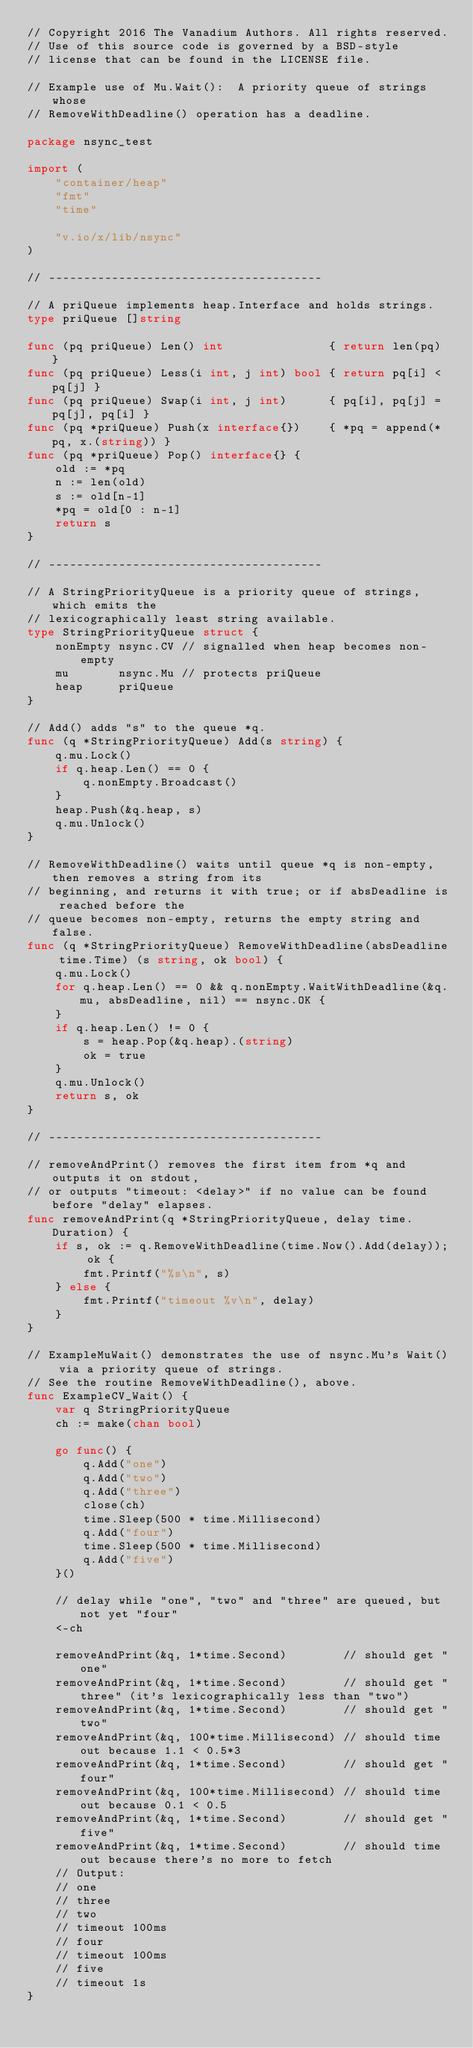<code> <loc_0><loc_0><loc_500><loc_500><_Go_>// Copyright 2016 The Vanadium Authors. All rights reserved.
// Use of this source code is governed by a BSD-style
// license that can be found in the LICENSE file.

// Example use of Mu.Wait():  A priority queue of strings whose
// RemoveWithDeadline() operation has a deadline.

package nsync_test

import (
	"container/heap"
	"fmt"
	"time"

	"v.io/x/lib/nsync"
)

// ---------------------------------------

// A priQueue implements heap.Interface and holds strings.
type priQueue []string

func (pq priQueue) Len() int               { return len(pq) }
func (pq priQueue) Less(i int, j int) bool { return pq[i] < pq[j] }
func (pq priQueue) Swap(i int, j int)      { pq[i], pq[j] = pq[j], pq[i] }
func (pq *priQueue) Push(x interface{})    { *pq = append(*pq, x.(string)) }
func (pq *priQueue) Pop() interface{} {
	old := *pq
	n := len(old)
	s := old[n-1]
	*pq = old[0 : n-1]
	return s
}

// ---------------------------------------

// A StringPriorityQueue is a priority queue of strings, which emits the
// lexicographically least string available.
type StringPriorityQueue struct {
	nonEmpty nsync.CV // signalled when heap becomes non-empty
	mu       nsync.Mu // protects priQueue
	heap     priQueue
}

// Add() adds "s" to the queue *q.
func (q *StringPriorityQueue) Add(s string) {
	q.mu.Lock()
	if q.heap.Len() == 0 {
		q.nonEmpty.Broadcast()
	}
	heap.Push(&q.heap, s)
	q.mu.Unlock()
}

// RemoveWithDeadline() waits until queue *q is non-empty, then removes a string from its
// beginning, and returns it with true; or if absDeadline is reached before the
// queue becomes non-empty, returns the empty string and false.
func (q *StringPriorityQueue) RemoveWithDeadline(absDeadline time.Time) (s string, ok bool) {
	q.mu.Lock()
	for q.heap.Len() == 0 && q.nonEmpty.WaitWithDeadline(&q.mu, absDeadline, nil) == nsync.OK {
	}
	if q.heap.Len() != 0 {
		s = heap.Pop(&q.heap).(string)
		ok = true
	}
	q.mu.Unlock()
	return s, ok
}

// ---------------------------------------

// removeAndPrint() removes the first item from *q and outputs it on stdout,
// or outputs "timeout: <delay>" if no value can be found before "delay" elapses.
func removeAndPrint(q *StringPriorityQueue, delay time.Duration) {
	if s, ok := q.RemoveWithDeadline(time.Now().Add(delay)); ok {
		fmt.Printf("%s\n", s)
	} else {
		fmt.Printf("timeout %v\n", delay)
	}
}

// ExampleMuWait() demonstrates the use of nsync.Mu's Wait() via a priority queue of strings.
// See the routine RemoveWithDeadline(), above.
func ExampleCV_Wait() {
	var q StringPriorityQueue
	ch := make(chan bool)

	go func() {
		q.Add("one")
		q.Add("two")
		q.Add("three")
		close(ch)
		time.Sleep(500 * time.Millisecond)
		q.Add("four")
		time.Sleep(500 * time.Millisecond)
		q.Add("five")
	}()

	// delay while "one", "two" and "three" are queued, but not yet "four"
	<-ch

	removeAndPrint(&q, 1*time.Second)        // should get "one"
	removeAndPrint(&q, 1*time.Second)        // should get "three" (it's lexicographically less than "two")
	removeAndPrint(&q, 1*time.Second)        // should get "two"
	removeAndPrint(&q, 100*time.Millisecond) // should time out because 1.1 < 0.5*3
	removeAndPrint(&q, 1*time.Second)        // should get "four"
	removeAndPrint(&q, 100*time.Millisecond) // should time out because 0.1 < 0.5
	removeAndPrint(&q, 1*time.Second)        // should get "five"
	removeAndPrint(&q, 1*time.Second)        // should time out because there's no more to fetch
	// Output:
	// one
	// three
	// two
	// timeout 100ms
	// four
	// timeout 100ms
	// five
	// timeout 1s
}
</code> 